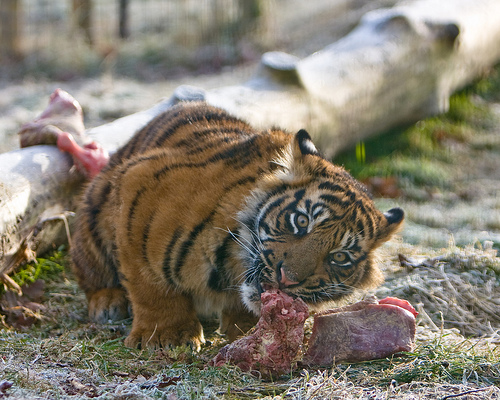<image>
Can you confirm if the meat is to the left of the tiger? No. The meat is not to the left of the tiger. From this viewpoint, they have a different horizontal relationship. Where is the tiger in relation to the tree? Is it behind the tree? No. The tiger is not behind the tree. From this viewpoint, the tiger appears to be positioned elsewhere in the scene. Is there a tiger in the meat? No. The tiger is not contained within the meat. These objects have a different spatial relationship. Is the tiger next to the meat? Yes. The tiger is positioned adjacent to the meat, located nearby in the same general area. 